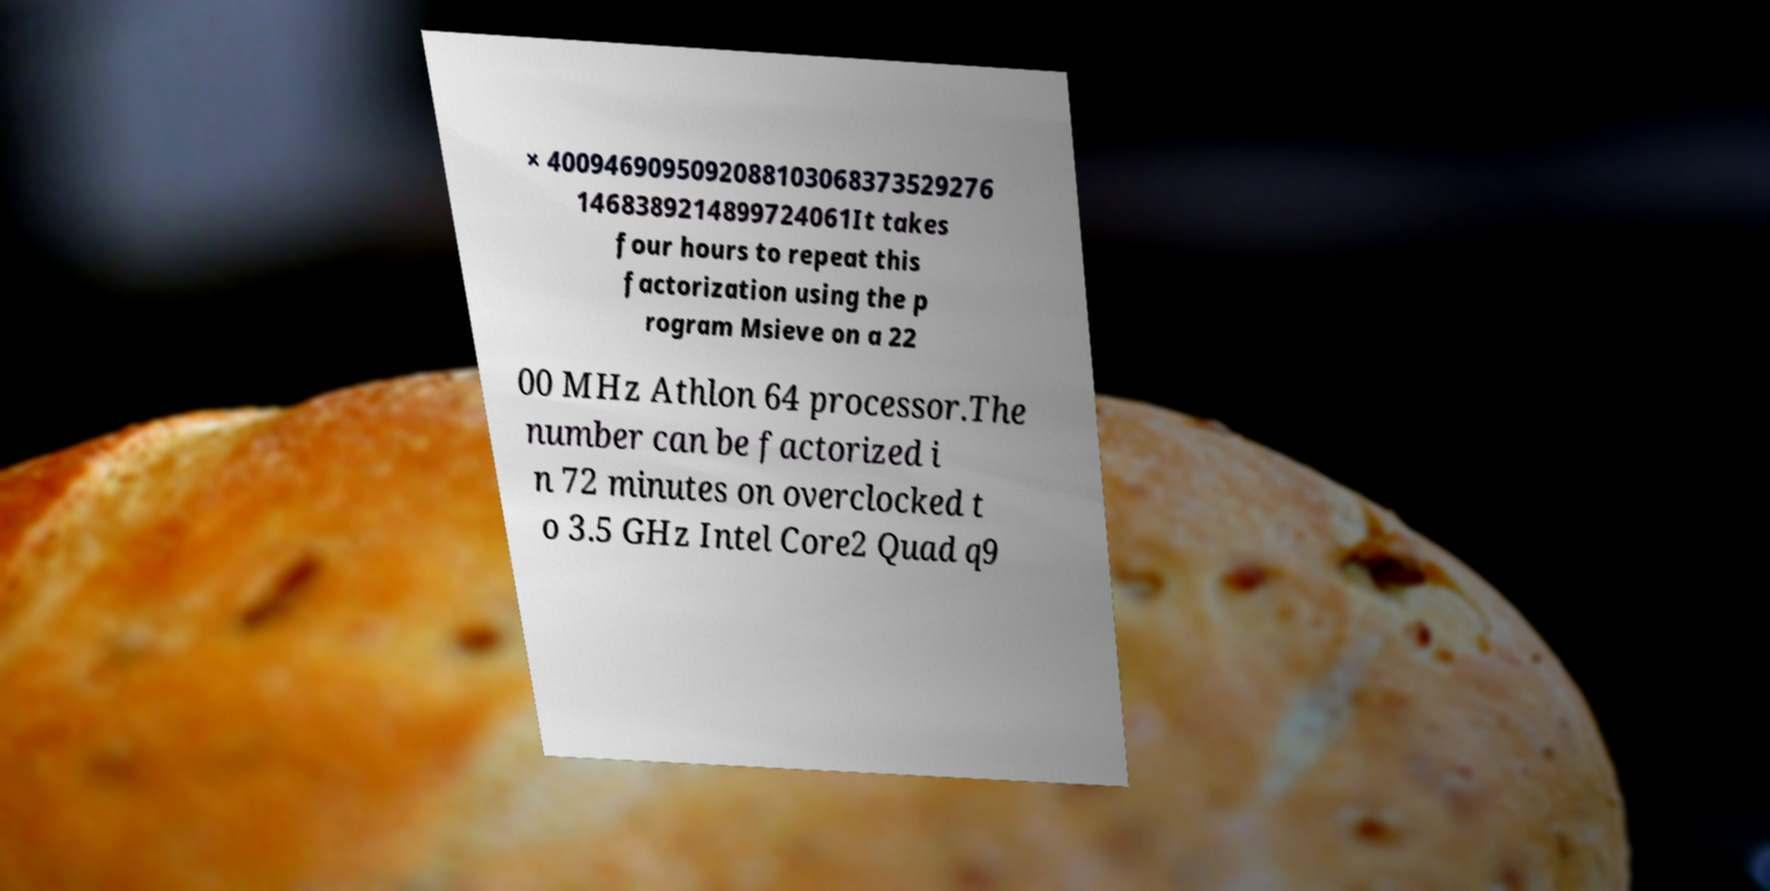Can you read and provide the text displayed in the image?This photo seems to have some interesting text. Can you extract and type it out for me? × 4009469095092088103068373529276 1468389214899724061It takes four hours to repeat this factorization using the p rogram Msieve on a 22 00 MHz Athlon 64 processor.The number can be factorized i n 72 minutes on overclocked t o 3.5 GHz Intel Core2 Quad q9 